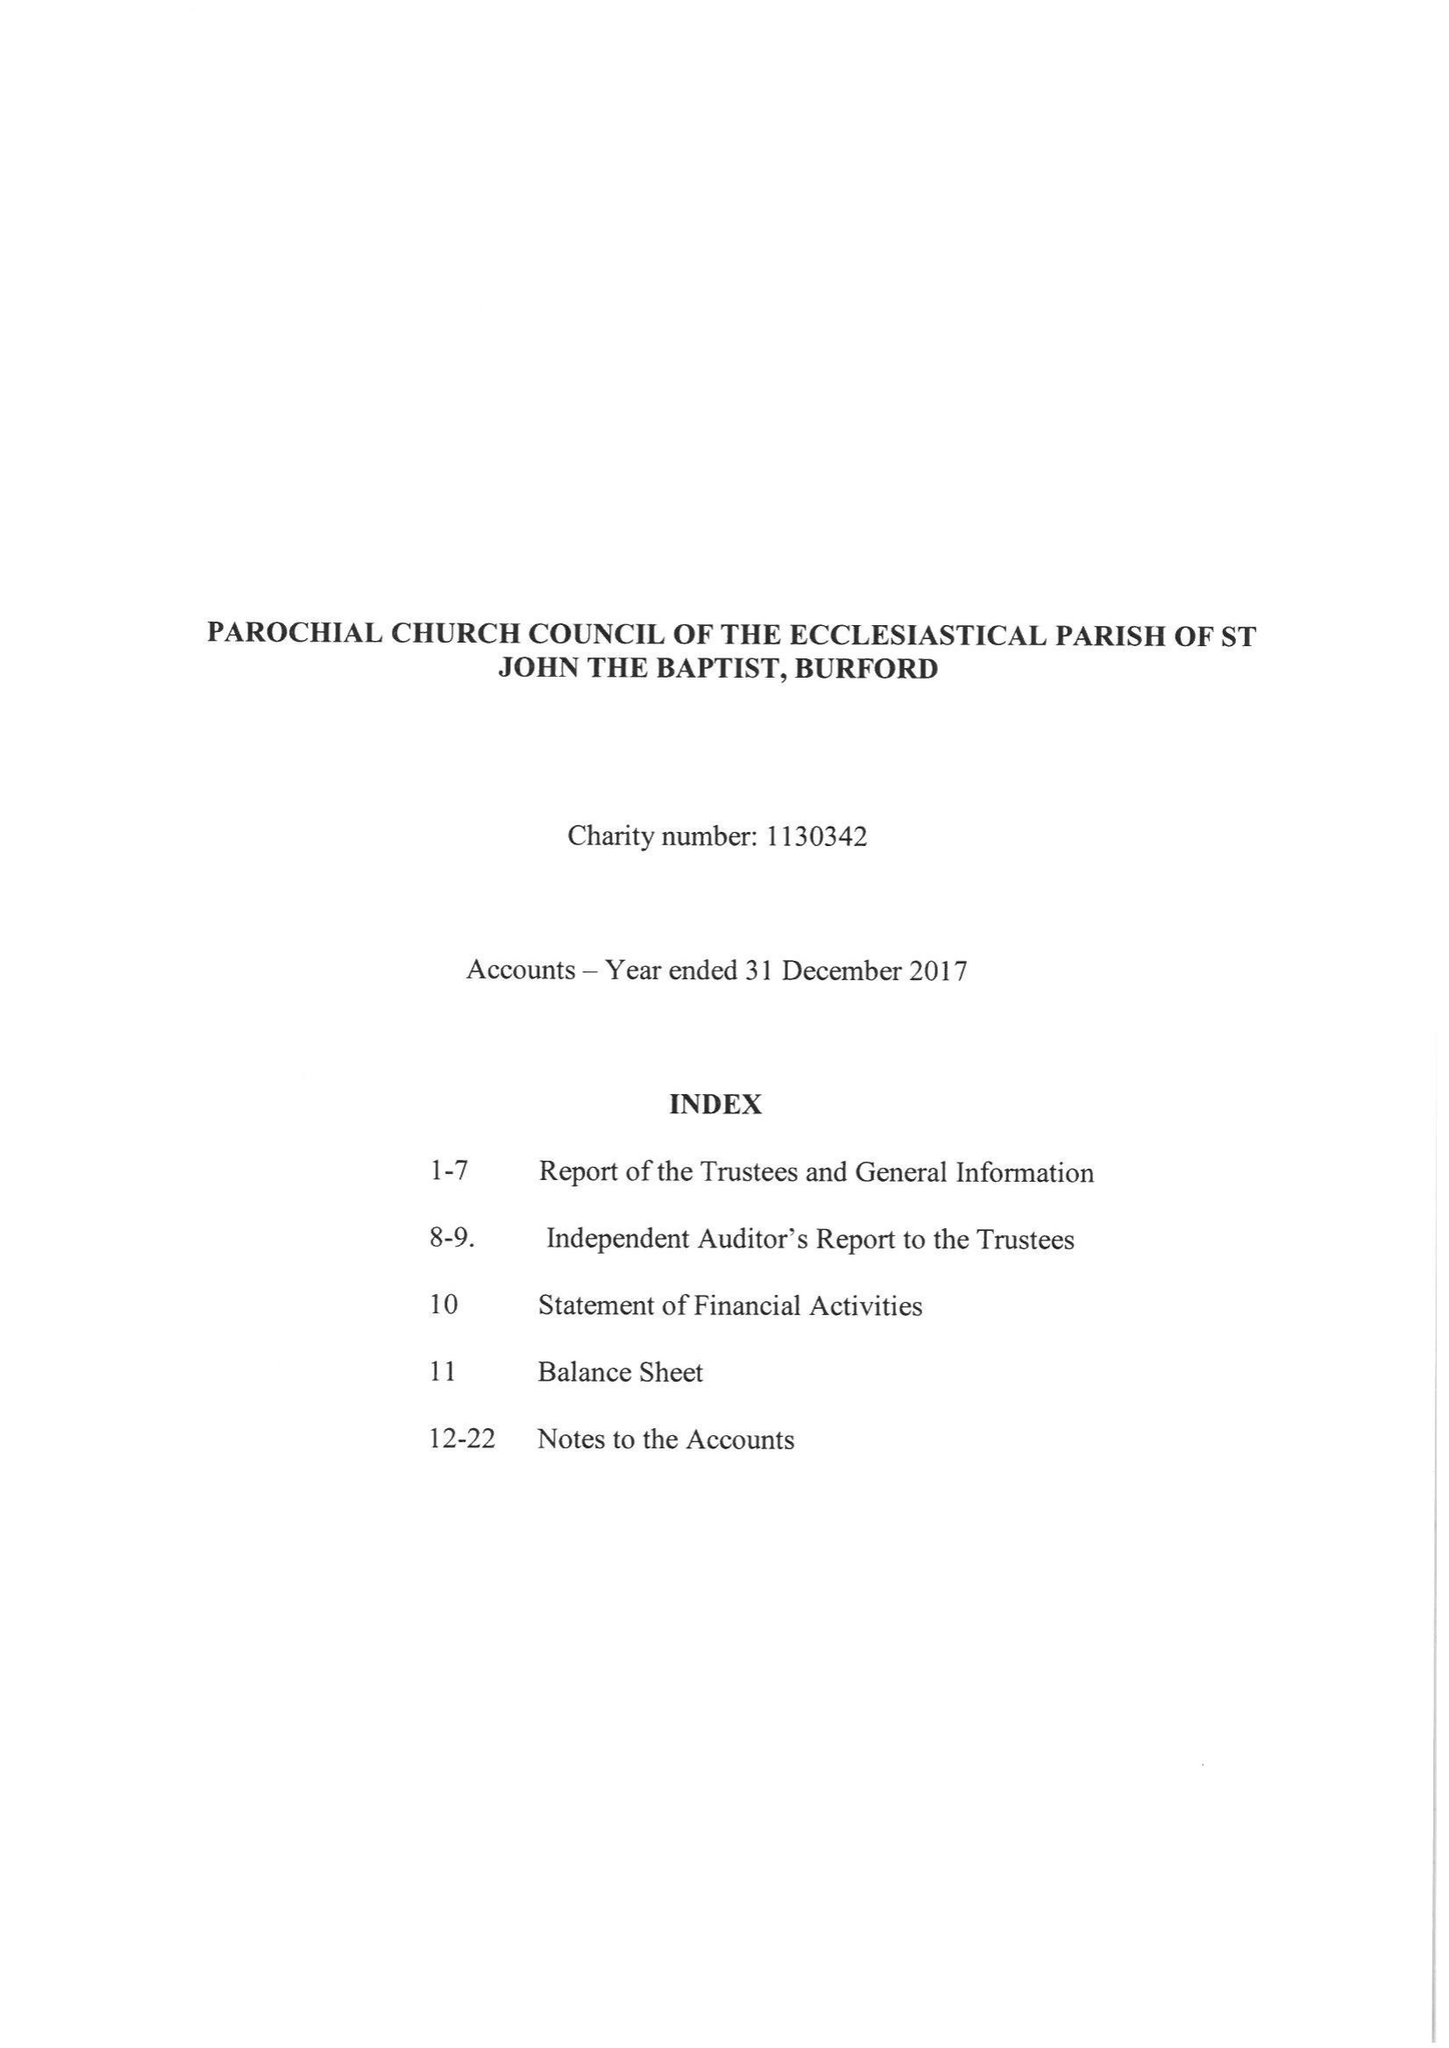What is the value for the spending_annually_in_british_pounds?
Answer the question using a single word or phrase. 534783.00 